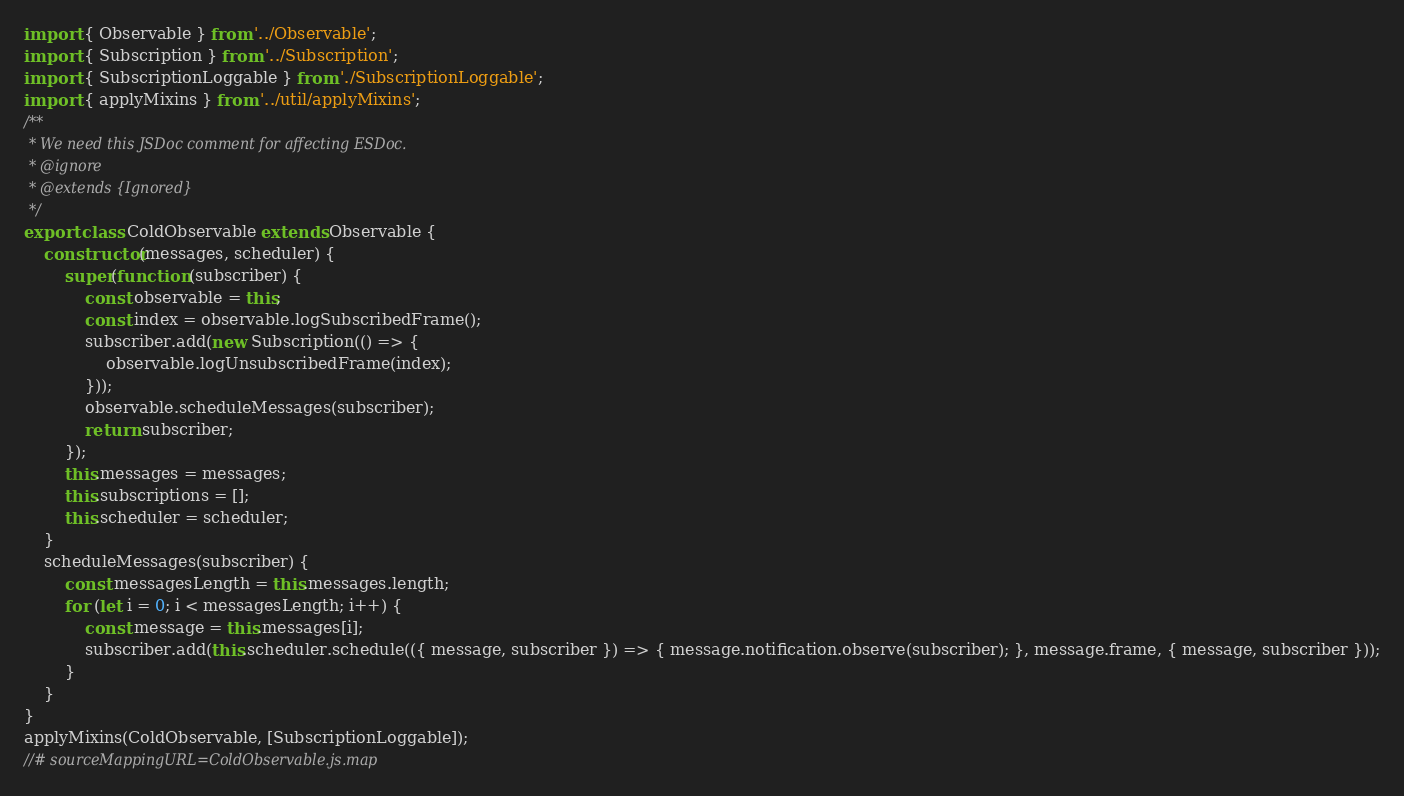<code> <loc_0><loc_0><loc_500><loc_500><_JavaScript_>import { Observable } from '../Observable';
import { Subscription } from '../Subscription';
import { SubscriptionLoggable } from './SubscriptionLoggable';
import { applyMixins } from '../util/applyMixins';
/**
 * We need this JSDoc comment for affecting ESDoc.
 * @ignore
 * @extends {Ignored}
 */
export class ColdObservable extends Observable {
    constructor(messages, scheduler) {
        super(function (subscriber) {
            const observable = this;
            const index = observable.logSubscribedFrame();
            subscriber.add(new Subscription(() => {
                observable.logUnsubscribedFrame(index);
            }));
            observable.scheduleMessages(subscriber);
            return subscriber;
        });
        this.messages = messages;
        this.subscriptions = [];
        this.scheduler = scheduler;
    }
    scheduleMessages(subscriber) {
        const messagesLength = this.messages.length;
        for (let i = 0; i < messagesLength; i++) {
            const message = this.messages[i];
            subscriber.add(this.scheduler.schedule(({ message, subscriber }) => { message.notification.observe(subscriber); }, message.frame, { message, subscriber }));
        }
    }
}
applyMixins(ColdObservable, [SubscriptionLoggable]);
//# sourceMappingURL=ColdObservable.js.map</code> 